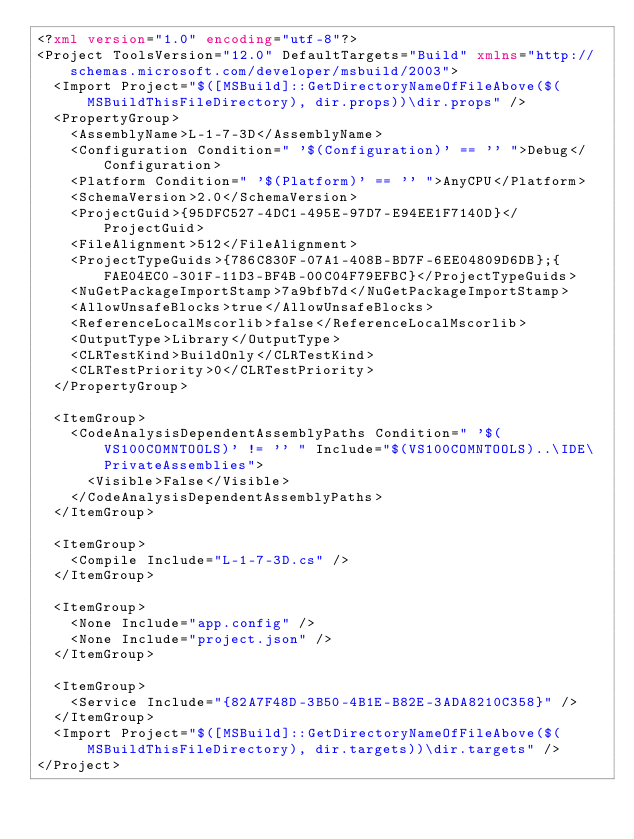Convert code to text. <code><loc_0><loc_0><loc_500><loc_500><_XML_><?xml version="1.0" encoding="utf-8"?>
<Project ToolsVersion="12.0" DefaultTargets="Build" xmlns="http://schemas.microsoft.com/developer/msbuild/2003">
  <Import Project="$([MSBuild]::GetDirectoryNameOfFileAbove($(MSBuildThisFileDirectory), dir.props))\dir.props" />
  <PropertyGroup>
    <AssemblyName>L-1-7-3D</AssemblyName>
    <Configuration Condition=" '$(Configuration)' == '' ">Debug</Configuration>
    <Platform Condition=" '$(Platform)' == '' ">AnyCPU</Platform>
    <SchemaVersion>2.0</SchemaVersion>
    <ProjectGuid>{95DFC527-4DC1-495E-97D7-E94EE1F7140D}</ProjectGuid>
    <FileAlignment>512</FileAlignment>
    <ProjectTypeGuids>{786C830F-07A1-408B-BD7F-6EE04809D6DB};{FAE04EC0-301F-11D3-BF4B-00C04F79EFBC}</ProjectTypeGuids>
    <NuGetPackageImportStamp>7a9bfb7d</NuGetPackageImportStamp>
    <AllowUnsafeBlocks>true</AllowUnsafeBlocks>
    <ReferenceLocalMscorlib>false</ReferenceLocalMscorlib>
    <OutputType>Library</OutputType>
    <CLRTestKind>BuildOnly</CLRTestKind>
    <CLRTestPriority>0</CLRTestPriority>
  </PropertyGroup>

  <ItemGroup>
    <CodeAnalysisDependentAssemblyPaths Condition=" '$(VS100COMNTOOLS)' != '' " Include="$(VS100COMNTOOLS)..\IDE\PrivateAssemblies">
      <Visible>False</Visible>
    </CodeAnalysisDependentAssemblyPaths>
  </ItemGroup>

  <ItemGroup>
    <Compile Include="L-1-7-3D.cs" />
  </ItemGroup>

  <ItemGroup>
    <None Include="app.config" />
    <None Include="project.json" />
  </ItemGroup>

  <ItemGroup>
    <Service Include="{82A7F48D-3B50-4B1E-B82E-3ADA8210C358}" />
  </ItemGroup>
  <Import Project="$([MSBuild]::GetDirectoryNameOfFileAbove($(MSBuildThisFileDirectory), dir.targets))\dir.targets" />
</Project>
</code> 